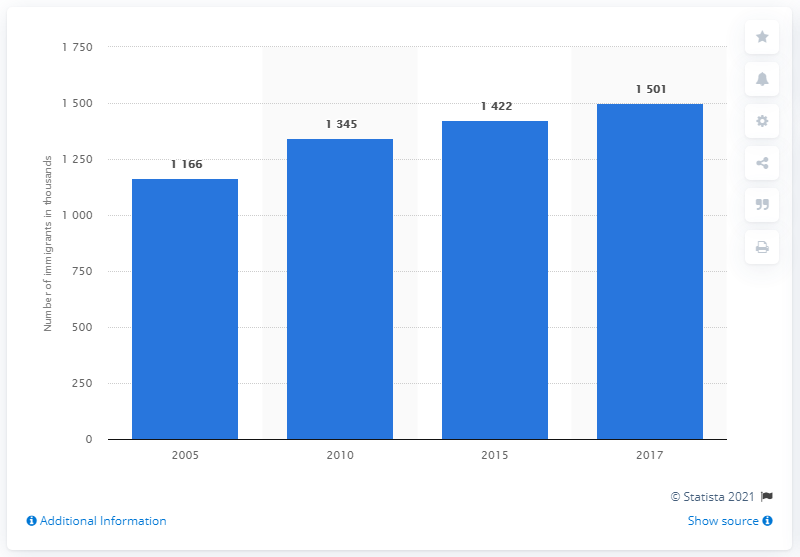Point out several critical features in this image. In 2010, there were 134,500 immigrants living in Bangladesh. 